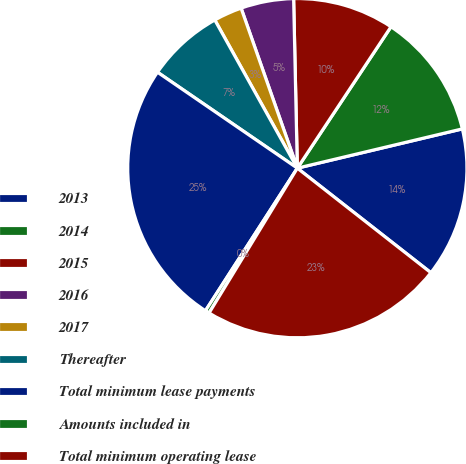Convert chart to OTSL. <chart><loc_0><loc_0><loc_500><loc_500><pie_chart><fcel>2013<fcel>2014<fcel>2015<fcel>2016<fcel>2017<fcel>Thereafter<fcel>Total minimum lease payments<fcel>Amounts included in<fcel>Total minimum operating lease<nl><fcel>14.29%<fcel>11.97%<fcel>9.66%<fcel>5.03%<fcel>2.71%<fcel>7.34%<fcel>25.46%<fcel>0.4%<fcel>23.14%<nl></chart> 